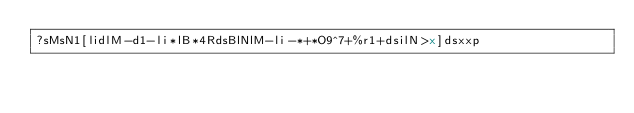<code> <loc_0><loc_0><loc_500><loc_500><_dc_>?sMsN1[lidlM-d1-li*lB*4RdsBlNlM-li-*+*O9^7+%r1+dsilN>x]dsxxp</code> 